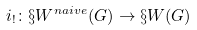<formula> <loc_0><loc_0><loc_500><loc_500>i _ { ! } \colon \S W ^ { n a i v e } ( G ) \to \S W ( G )</formula> 